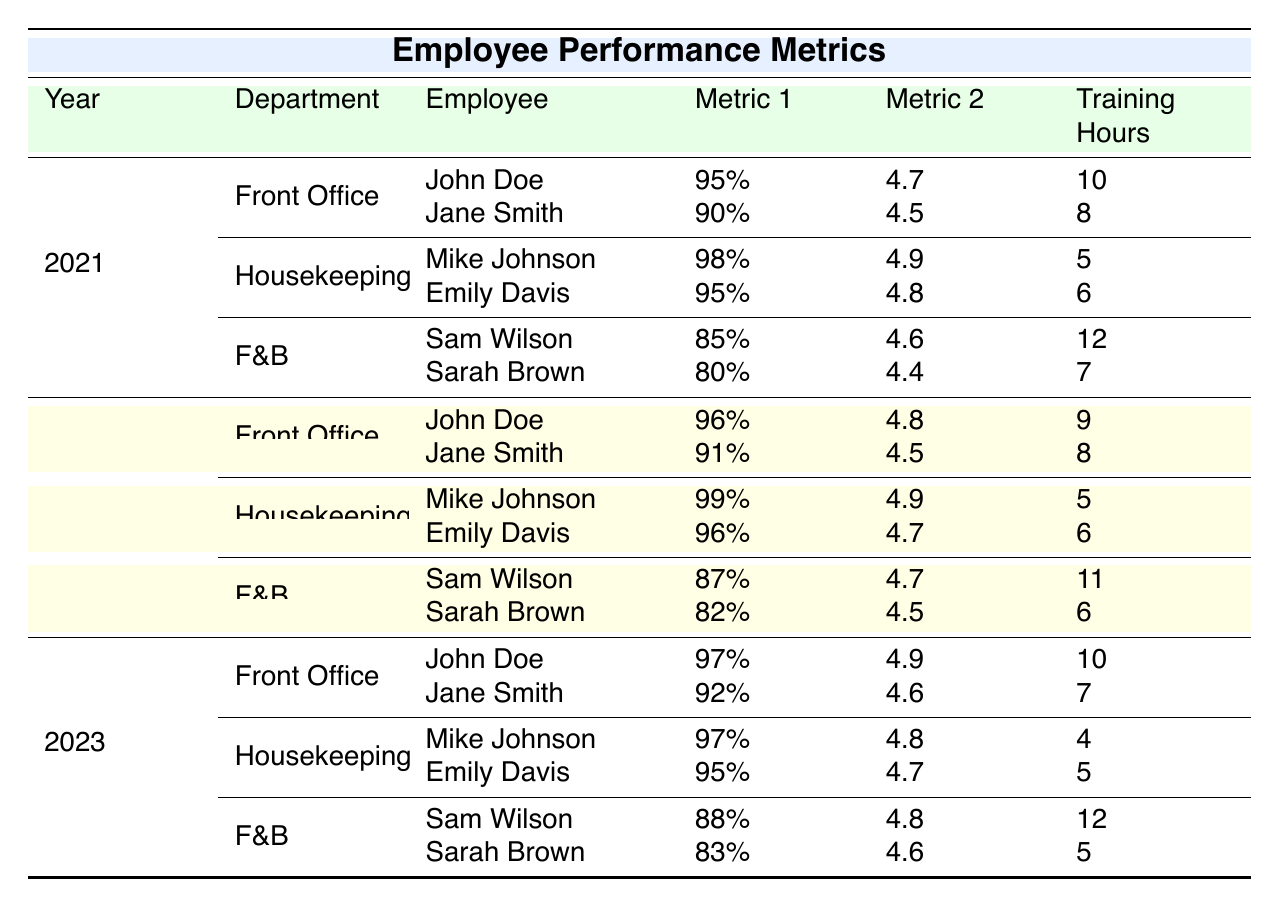What was John Doe's Check-In Efficiency in 2022? In 2022, John Doe's Check-In Efficiency as listed under the Front Office department is 96%.
Answer: 96% Which employee had the highest Room Cleanliness Score in 2021? Mike Johnson had the highest Room Cleanliness Score of 98% in 2021, as shown in the Housekeeping section of the table.
Answer: Mike Johnson Did Sarah Brown's Customer Satisfaction Score improve from 2021 to 2023? In 2021, Sarah Brown had a Customer Satisfaction Score of 4.4, which increased to 4.6 in 2023. Therefore, her score improved.
Answer: Yes What is the average Check-In Efficiency of the Front Office department in 2023? The Check-In Efficiencies for the Front Office in 2023 are 97% (John Doe) and 92% (Jane Smith). To find the average: (97 + 92) / 2 = 94.5%.
Answer: 94.5% Which department had the lowest average Training Hours in 2023? The Training Hours for each department in 2023 are: Front Office (10, 7), Housekeeping (4, 5), and Food and Beverage (12, 5). Calculating the averages gives: Front Office 8.5, Housekeeping 4.5, and Food & Beverage 8.5. Housekeeping has the lowest average Training Hours of 4.5.
Answer: Housekeeping How many employees worked in the Food and Beverage department in 2022? In 2022, there were two employees listed under the Food and Beverage department: Sam Wilson and Sarah Brown. Therefore, the total is 2.
Answer: 2 Did Emily Davis receive more or less Training Hours in 2023 compared to 2021? Emily Davis received 6 Training Hours in 2021 and 5 in 2023. This indicates she received less Training Hours in 2023 compared to 2021.
Answer: Less What was the increase in Guest Feedback Score for Mike Johnson from 2021 to 2023? Mike Johnson's Guest Feedback Score was 4.9 in 2021 and decreased to 4.8 in 2023. The change is calculated as follows: 4.8 - 4.9 = -0.1, indicating a decrease.
Answer: Decrease What is the overall average Customer Satisfaction Score for all employees in 2022? The Customer Satisfaction Scores in 2022 are 4.8 (John Doe), 4.5 (Jane Smith), 4.9 (Mike Johnson), 4.7 (Emily Davis), 4.7 (Sam Wilson), and 4.5 (Sarah Brown). Adding these scores yields: 4.8 + 4.5 + 4.9 + 4.7 + 4.7 + 4.5 = 29.1. Dividing by the number of employees (6) gives: 29.1 / 6 = 4.85.
Answer: 4.85 